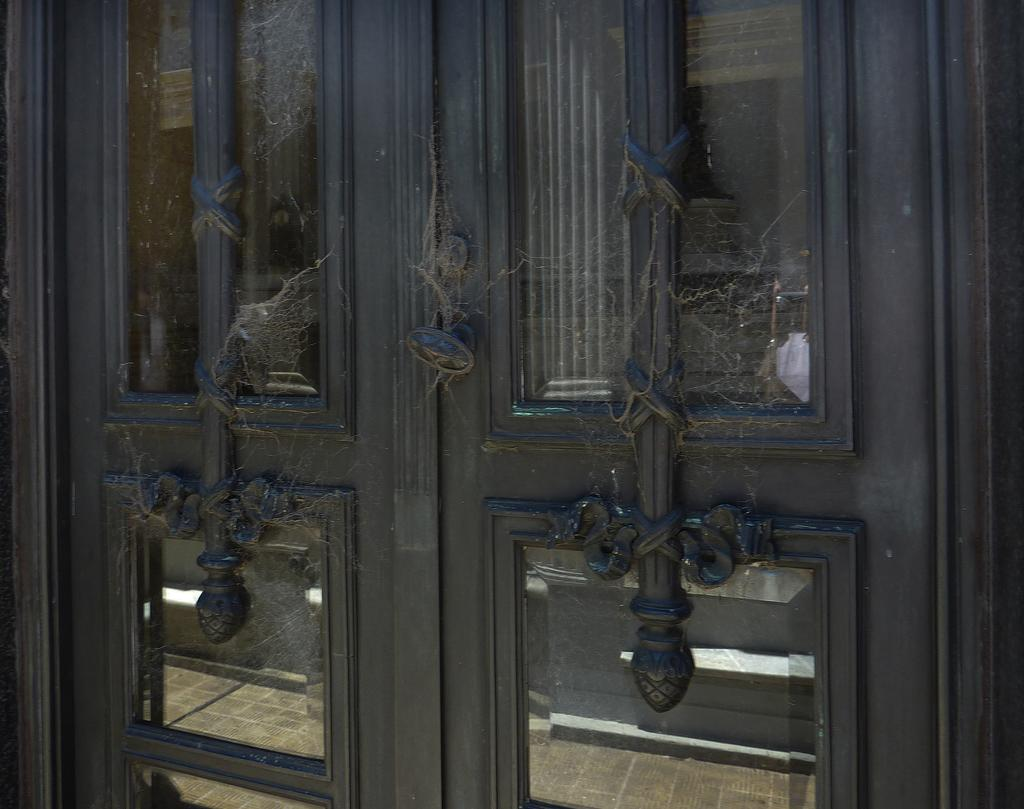What type of doors are visible in the image? There are doors with glass panes in the image. Can you describe any patterns or designs in the image? Yes, there are designs in the image. What additional element can be seen in the image? There are spider webs in the image. What type of pear is hanging from the spider webs in the image? There is no pear present in the image; it features doors with glass panes, designs, and spider webs. What type of blade can be seen cutting through the doors in the image? There is no blade present in the image; it only features doors with glass panes, designs, and spider webs. 